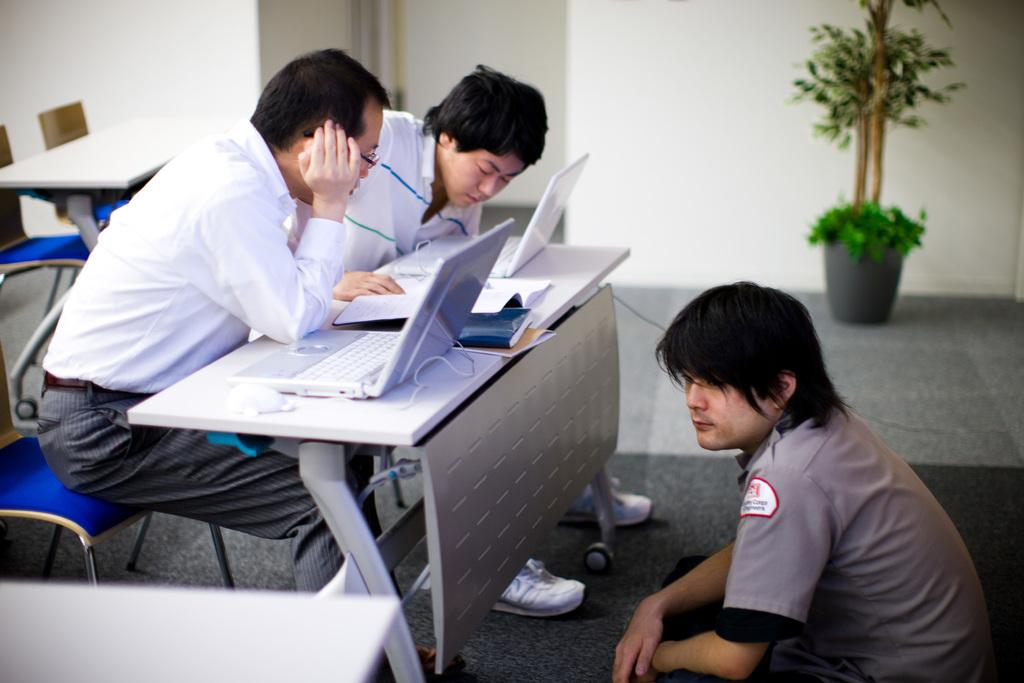How many people are seated in the image? There are two people seated in the image. What are the people doing while seated? The people are working on laptops. Where are the laptops placed? The laptops are on a table. Can you describe the gender of one of the seated individuals? There is a man seated in the image. What type of vegetation can be seen in the image? There is a plant visible in the image. What type of kettle is being used by the man in the image? There is no kettle present in the image; the man is working on a laptop. How does the whip affect the work being done by the people in the image? There is no whip present in the image, and therefore, it cannot affect the work being done by the people. 